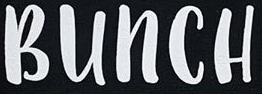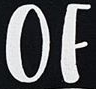Read the text content from these images in order, separated by a semicolon. BUNCH; OF 